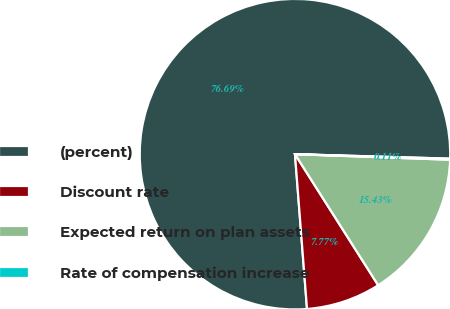Convert chart. <chart><loc_0><loc_0><loc_500><loc_500><pie_chart><fcel>(percent)<fcel>Discount rate<fcel>Expected return on plan assets<fcel>Rate of compensation increase<nl><fcel>76.7%<fcel>7.77%<fcel>15.43%<fcel>0.11%<nl></chart> 